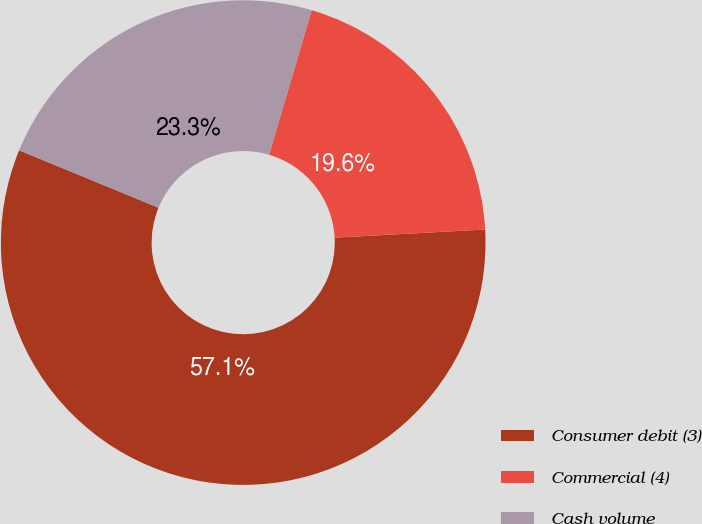Convert chart to OTSL. <chart><loc_0><loc_0><loc_500><loc_500><pie_chart><fcel>Consumer debit (3)<fcel>Commercial (4)<fcel>Cash volume<nl><fcel>57.08%<fcel>19.58%<fcel>23.34%<nl></chart> 